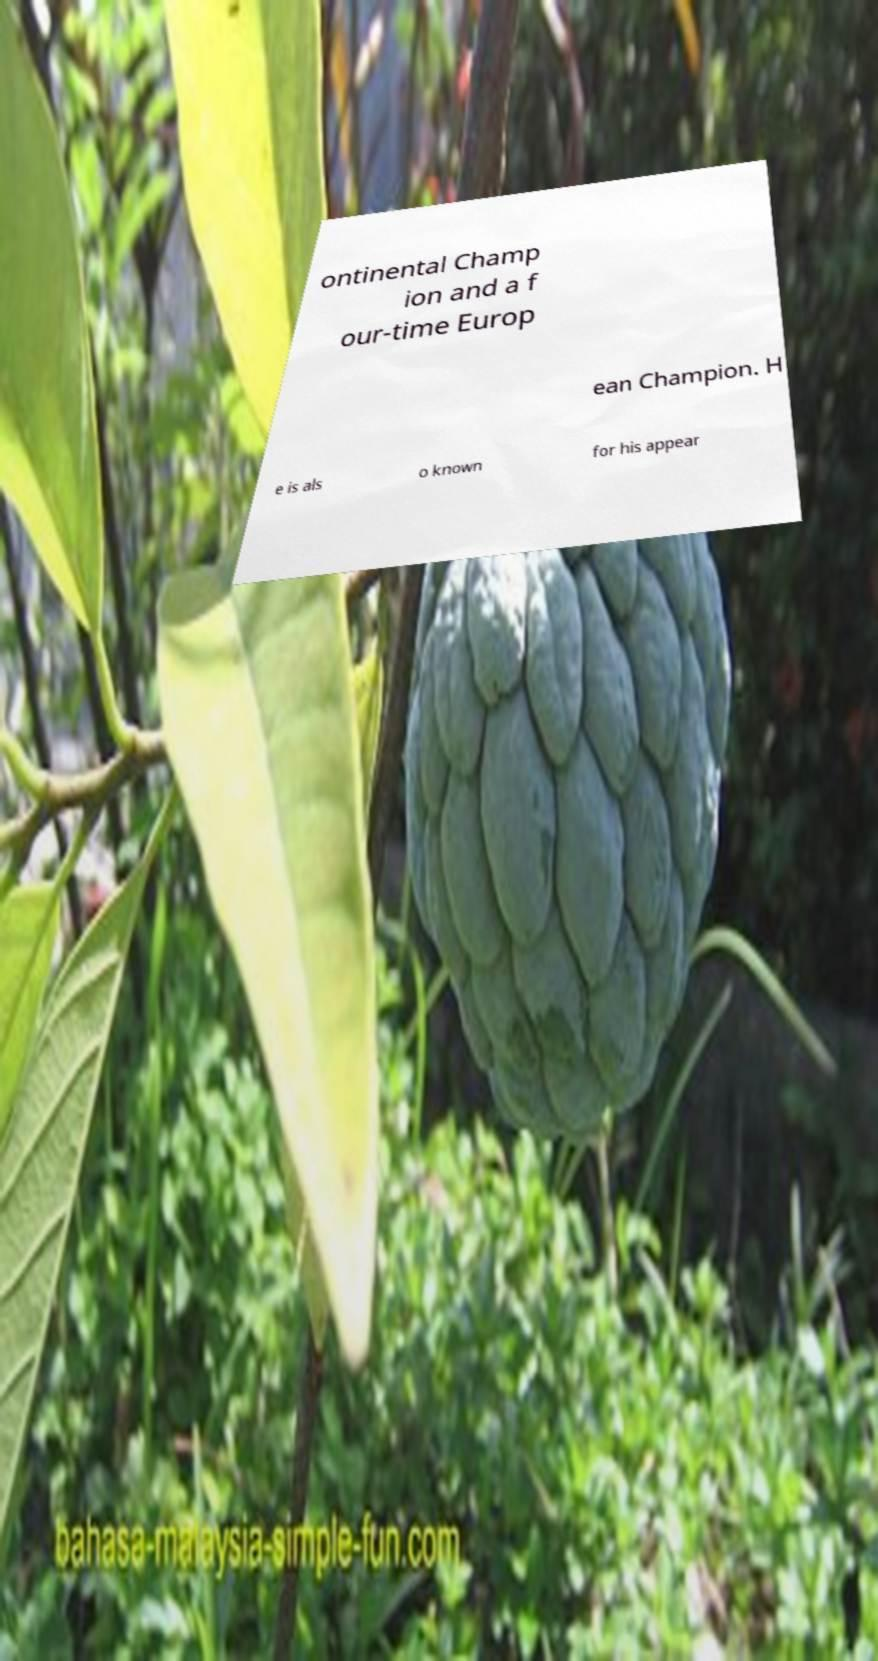What messages or text are displayed in this image? I need them in a readable, typed format. ontinental Champ ion and a f our-time Europ ean Champion. H e is als o known for his appear 